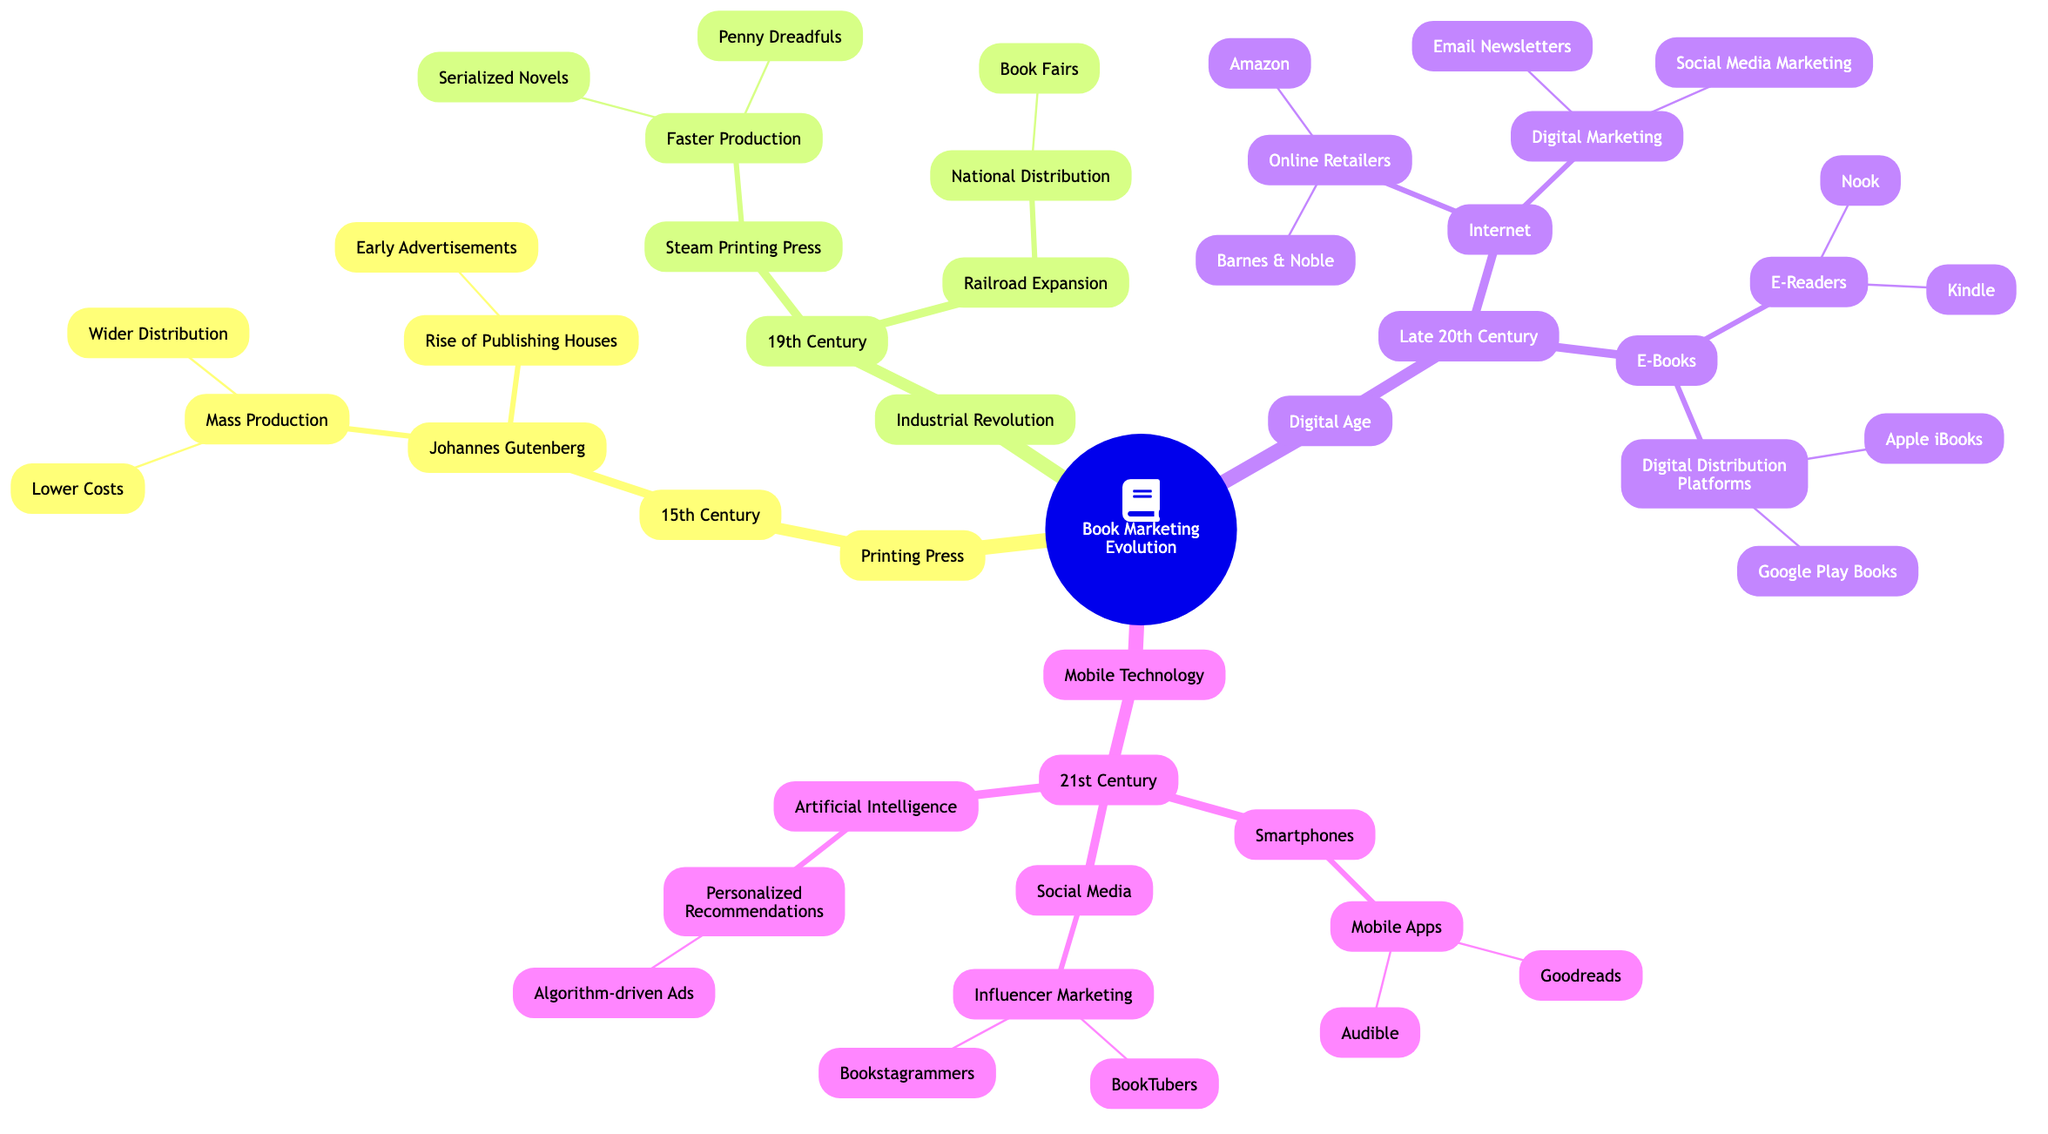What is the main technological advancement discussed in the 15th Century? The diagram specifies "Printing Press" as the primary technological advancement for the 15th Century.
Answer: Printing Press How many main branches are in the diagram? Counting the main branches labeled as "Printing Press," "Industrial Revolution," "Digital Age," and "Mobile Technology" shows there are four main branches in the diagram.
Answer: 4 What book marketing strategy emerged due to the Industrial Revolution? The diagram indicates that "Serialized Novels" and "Penny Dreadfuls" emerged as strategies due to the faster production from the Steam Printing Press during the Industrial Revolution.
Answer: Serialized Novels Which decade saw the rise of Online Retailers? Referring to the "Digital Age" section, the diagram clearly states the rise of Online Retailers occurred in the "Late 20th Century."
Answer: Late 20th Century What is one influence of Artificial Intelligence on book marketing strategies? By examining the "Artificial Intelligence" section, it highlights "Personalized Recommendations" as an influence on book marketing strategies.
Answer: Personalized Recommendations How do Smartphones influence modern book marketing? The "Mobile Technology" section specifies that "Mobile Apps," like Goodreads and Audible, show how Smartphones influence current book marketing practices.
Answer: Mobile Apps How does the Printing Press impact book distribution? Under "Mass Production," the diagram details that the Printing Press led to "Wider Distribution" and "Lower Costs," contributing to book distribution methods.
Answer: Wider Distribution What are two platforms for Digital Distribution mentioned in the Digital Age? In the section about Digital Distribution Platforms, it lists "Apple iBooks" and "Google Play Books" as two specific platforms for digital distribution.
Answer: Apple iBooks, Google Play Books What emerging marketing strategy is linked to Social Media in the 21st Century? The diagram identifies "Influencer Marketing" as a specific strategy related to Social Media in the 21st Century.
Answer: Influencer Marketing 